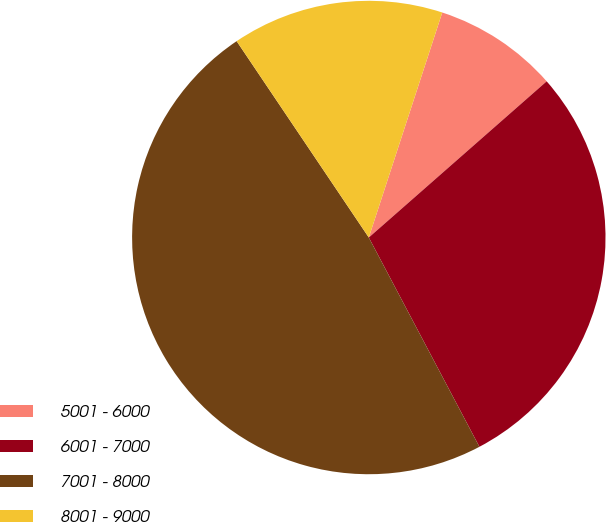Convert chart to OTSL. <chart><loc_0><loc_0><loc_500><loc_500><pie_chart><fcel>5001 - 6000<fcel>6001 - 7000<fcel>7001 - 8000<fcel>8001 - 9000<nl><fcel>8.51%<fcel>28.73%<fcel>48.31%<fcel>14.45%<nl></chart> 